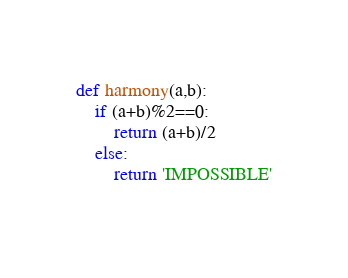Convert code to text. <code><loc_0><loc_0><loc_500><loc_500><_Python_>def harmony(a,b):
    if (a+b)%2==0:
        return (a+b)/2
    else:
        return 'IMPOSSIBLE'
    </code> 